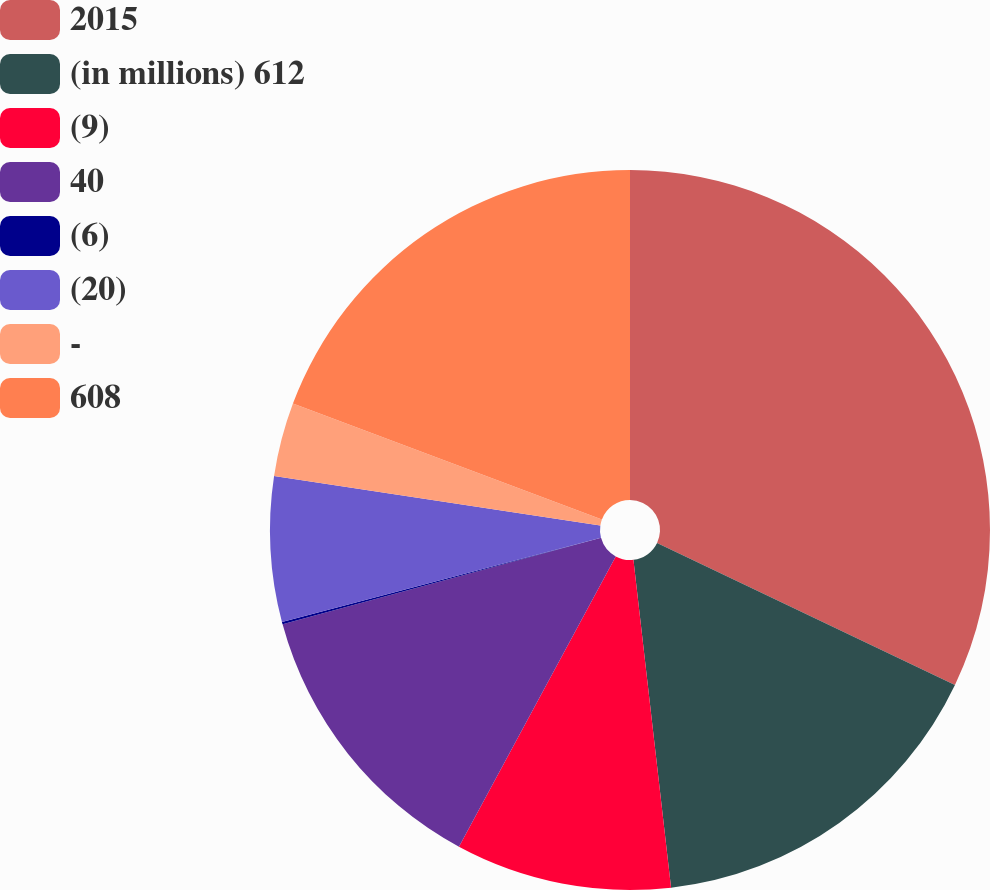<chart> <loc_0><loc_0><loc_500><loc_500><pie_chart><fcel>2015<fcel>(in millions) 612<fcel>(9)<fcel>40<fcel>(6)<fcel>(20)<fcel>-<fcel>608<nl><fcel>32.08%<fcel>16.1%<fcel>9.7%<fcel>12.9%<fcel>0.11%<fcel>6.51%<fcel>3.31%<fcel>19.29%<nl></chart> 